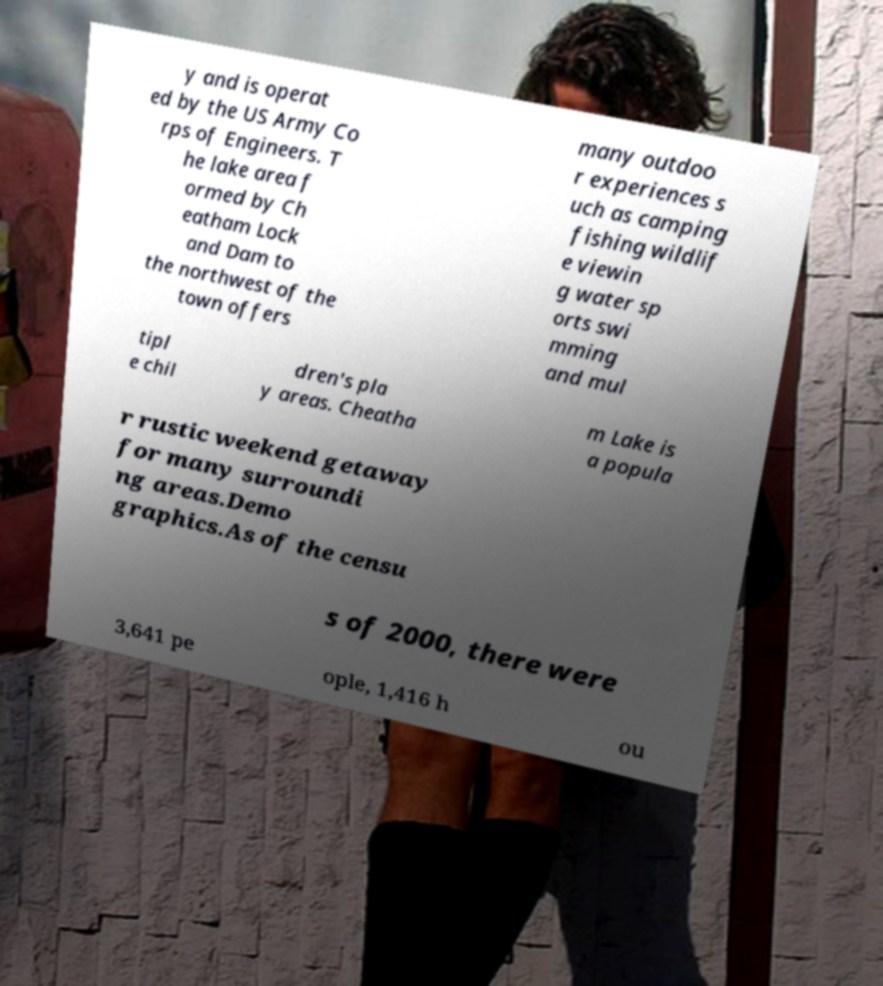What messages or text are displayed in this image? I need them in a readable, typed format. y and is operat ed by the US Army Co rps of Engineers. T he lake area f ormed by Ch eatham Lock and Dam to the northwest of the town offers many outdoo r experiences s uch as camping fishing wildlif e viewin g water sp orts swi mming and mul tipl e chil dren's pla y areas. Cheatha m Lake is a popula r rustic weekend getaway for many surroundi ng areas.Demo graphics.As of the censu s of 2000, there were 3,641 pe ople, 1,416 h ou 